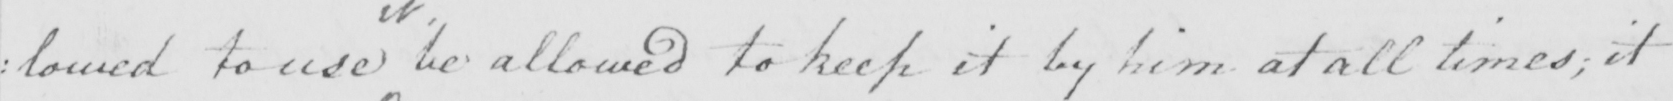What text is written in this handwritten line? : lowed to use be allowed to keep it by him at all times  ; it 